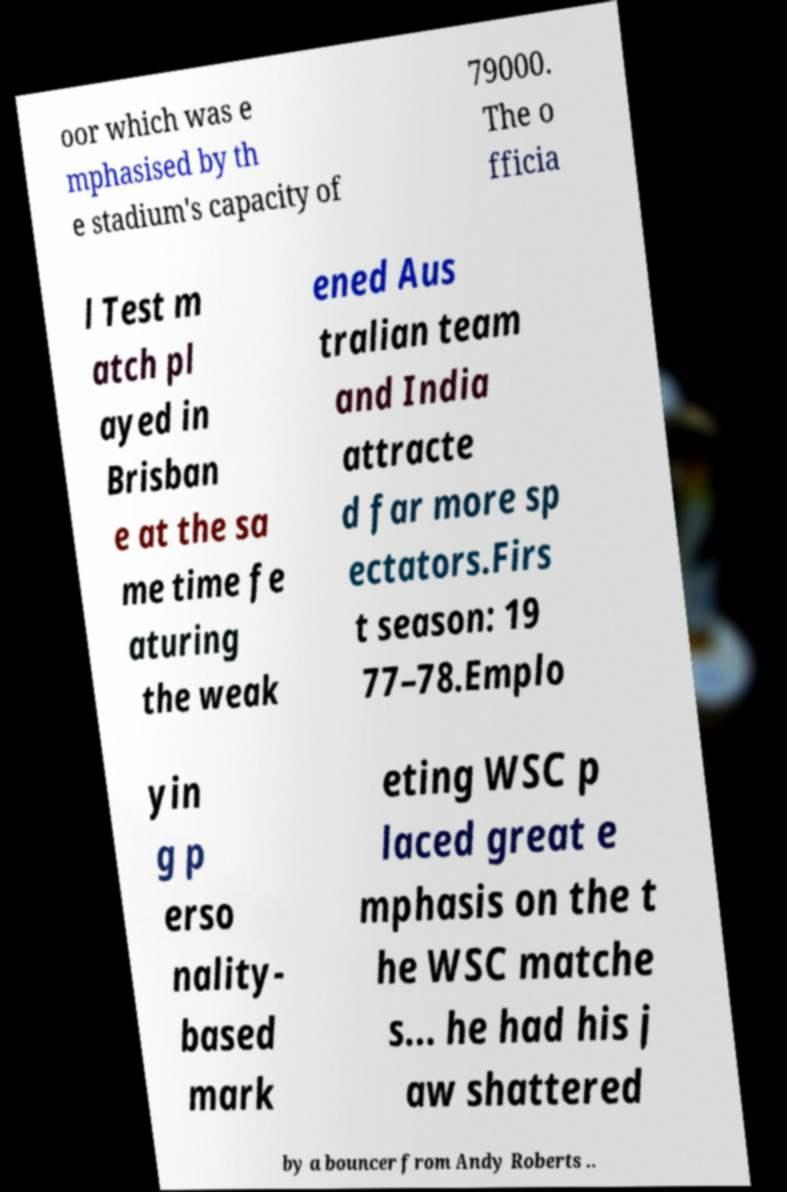Could you extract and type out the text from this image? oor which was e mphasised by th e stadium's capacity of 79000. The o fficia l Test m atch pl ayed in Brisban e at the sa me time fe aturing the weak ened Aus tralian team and India attracte d far more sp ectators.Firs t season: 19 77–78.Emplo yin g p erso nality- based mark eting WSC p laced great e mphasis on the t he WSC matche s... he had his j aw shattered by a bouncer from Andy Roberts .. 